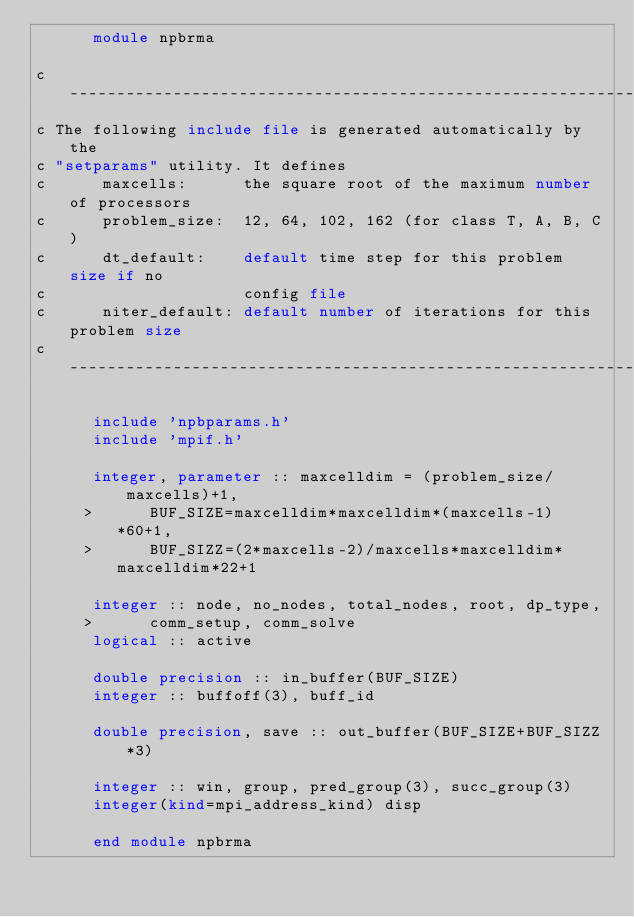<code> <loc_0><loc_0><loc_500><loc_500><_FORTRAN_>      module npbrma

c---------------------------------------------------------------------
c The following include file is generated automatically by the
c "setparams" utility. It defines 
c      maxcells:      the square root of the maximum number of processors
c      problem_size:  12, 64, 102, 162 (for class T, A, B, C)
c      dt_default:    default time step for this problem size if no
c                     config file
c      niter_default: default number of iterations for this problem size
c---------------------------------------------------------------------

      include 'npbparams.h'
      include 'mpif.h'

      integer, parameter :: maxcelldim = (problem_size/maxcells)+1,
     >      BUF_SIZE=maxcelldim*maxcelldim*(maxcells-1)*60+1,
     >      BUF_SIZZ=(2*maxcells-2)/maxcells*maxcelldim*maxcelldim*22+1

      integer :: node, no_nodes, total_nodes, root, dp_type,
     >      comm_setup, comm_solve
      logical :: active

      double precision :: in_buffer(BUF_SIZE)
      integer :: buffoff(3), buff_id

      double precision, save :: out_buffer(BUF_SIZE+BUF_SIZZ*3)

      integer :: win, group, pred_group(3), succ_group(3)
      integer(kind=mpi_address_kind) disp

      end module npbrma
</code> 